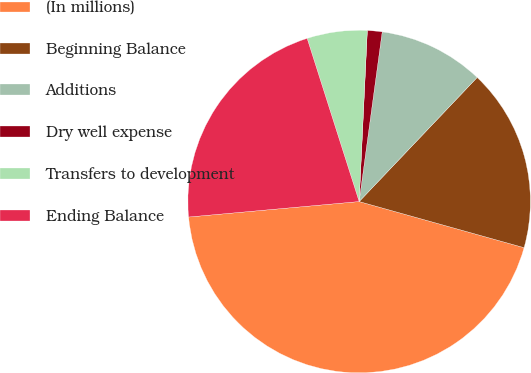Convert chart to OTSL. <chart><loc_0><loc_0><loc_500><loc_500><pie_chart><fcel>(In millions)<fcel>Beginning Balance<fcel>Additions<fcel>Dry well expense<fcel>Transfers to development<fcel>Ending Balance<nl><fcel>44.22%<fcel>17.24%<fcel>9.95%<fcel>1.39%<fcel>5.67%<fcel>21.53%<nl></chart> 